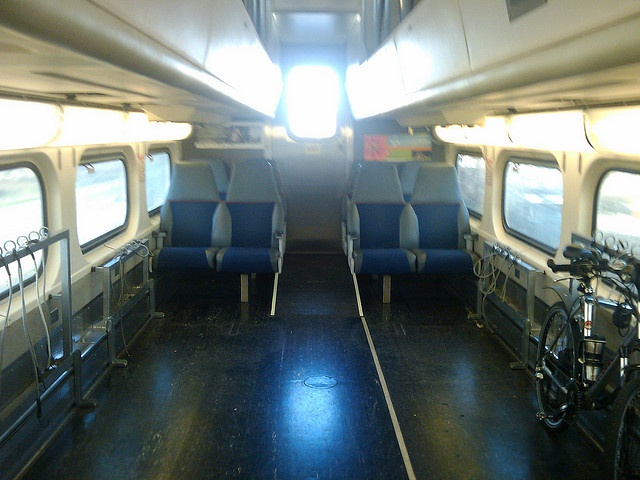Describe the objects in this image and their specific colors. I can see bicycle in darkgreen, black, gray, and purple tones, chair in darkgreen, gray, black, darkblue, and blue tones, chair in darkgreen, gray, black, blue, and darkblue tones, chair in darkgreen, gray, navy, black, and blue tones, and chair in darkgreen, gray, black, blue, and darkblue tones in this image. 